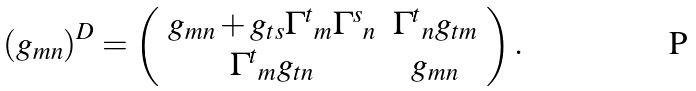Convert formula to latex. <formula><loc_0><loc_0><loc_500><loc_500>\left ( g _ { m n } \right ) ^ { D } = \left ( \begin{array} { c c } { { g _ { m n } + g _ { t s } { \Gamma ^ { t } } _ { m } { \Gamma ^ { s } } _ { n } } } & { { { \Gamma ^ { t } } _ { n } g _ { t m } } } \\ { { { \Gamma ^ { t } } _ { m } g _ { t n } } } & { { g _ { m n } } } \end{array} \right ) .</formula> 